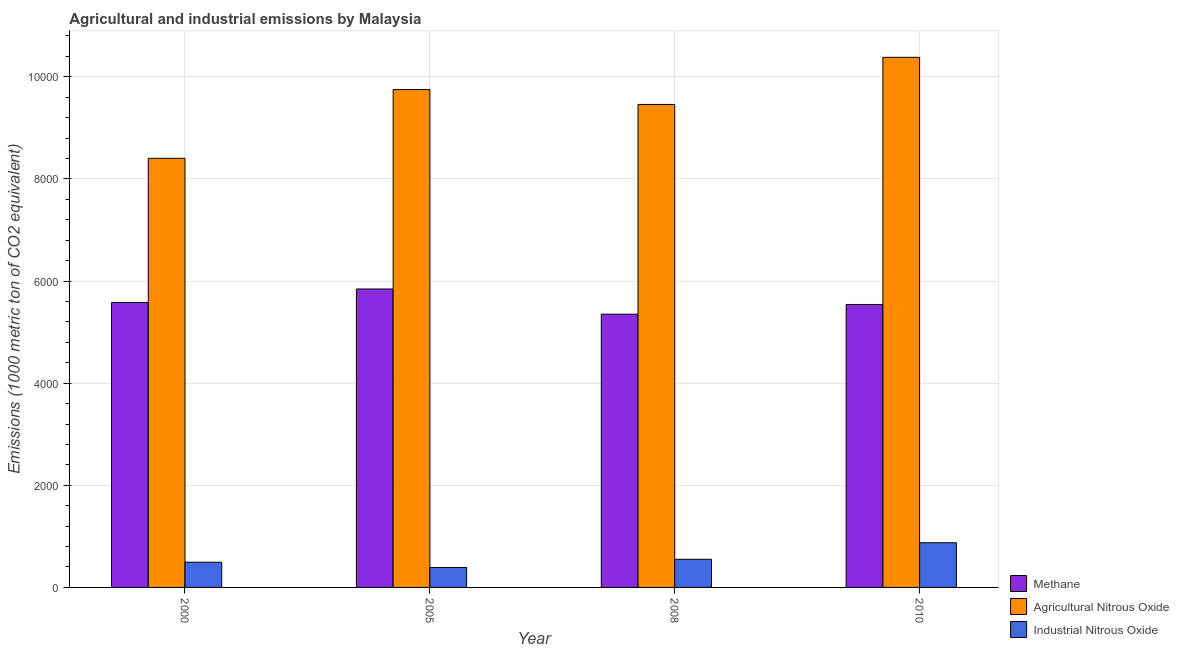What is the amount of agricultural nitrous oxide emissions in 2000?
Your answer should be compact. 8403.2. Across all years, what is the maximum amount of industrial nitrous oxide emissions?
Your answer should be very brief. 874.9. Across all years, what is the minimum amount of agricultural nitrous oxide emissions?
Give a very brief answer. 8403.2. In which year was the amount of agricultural nitrous oxide emissions minimum?
Keep it short and to the point. 2000. What is the total amount of methane emissions in the graph?
Keep it short and to the point. 2.23e+04. What is the difference between the amount of agricultural nitrous oxide emissions in 2005 and that in 2008?
Keep it short and to the point. 291.7. What is the difference between the amount of methane emissions in 2000 and the amount of industrial nitrous oxide emissions in 2008?
Provide a succinct answer. 228.9. What is the average amount of industrial nitrous oxide emissions per year?
Give a very brief answer. 577.65. In the year 2010, what is the difference between the amount of industrial nitrous oxide emissions and amount of methane emissions?
Offer a very short reply. 0. What is the ratio of the amount of industrial nitrous oxide emissions in 2000 to that in 2005?
Offer a very short reply. 1.26. Is the difference between the amount of industrial nitrous oxide emissions in 2000 and 2010 greater than the difference between the amount of agricultural nitrous oxide emissions in 2000 and 2010?
Provide a succinct answer. No. What is the difference between the highest and the second highest amount of agricultural nitrous oxide emissions?
Your answer should be very brief. 630.9. What is the difference between the highest and the lowest amount of methane emissions?
Ensure brevity in your answer.  493.7. What does the 3rd bar from the left in 2008 represents?
Offer a very short reply. Industrial Nitrous Oxide. What does the 3rd bar from the right in 2000 represents?
Your answer should be compact. Methane. Is it the case that in every year, the sum of the amount of methane emissions and amount of agricultural nitrous oxide emissions is greater than the amount of industrial nitrous oxide emissions?
Ensure brevity in your answer.  Yes. How many bars are there?
Give a very brief answer. 12. What is the difference between two consecutive major ticks on the Y-axis?
Your answer should be very brief. 2000. Does the graph contain any zero values?
Ensure brevity in your answer.  No. How many legend labels are there?
Keep it short and to the point. 3. What is the title of the graph?
Provide a succinct answer. Agricultural and industrial emissions by Malaysia. Does "Agricultural Nitrous Oxide" appear as one of the legend labels in the graph?
Offer a terse response. Yes. What is the label or title of the Y-axis?
Give a very brief answer. Emissions (1000 metric ton of CO2 equivalent). What is the Emissions (1000 metric ton of CO2 equivalent) in Methane in 2000?
Make the answer very short. 5579.2. What is the Emissions (1000 metric ton of CO2 equivalent) in Agricultural Nitrous Oxide in 2000?
Provide a succinct answer. 8403.2. What is the Emissions (1000 metric ton of CO2 equivalent) in Industrial Nitrous Oxide in 2000?
Ensure brevity in your answer.  493.8. What is the Emissions (1000 metric ton of CO2 equivalent) in Methane in 2005?
Keep it short and to the point. 5844. What is the Emissions (1000 metric ton of CO2 equivalent) of Agricultural Nitrous Oxide in 2005?
Your response must be concise. 9749.3. What is the Emissions (1000 metric ton of CO2 equivalent) in Industrial Nitrous Oxide in 2005?
Make the answer very short. 390.9. What is the Emissions (1000 metric ton of CO2 equivalent) in Methane in 2008?
Make the answer very short. 5350.3. What is the Emissions (1000 metric ton of CO2 equivalent) in Agricultural Nitrous Oxide in 2008?
Make the answer very short. 9457.6. What is the Emissions (1000 metric ton of CO2 equivalent) of Industrial Nitrous Oxide in 2008?
Your answer should be compact. 551. What is the Emissions (1000 metric ton of CO2 equivalent) of Methane in 2010?
Ensure brevity in your answer.  5540.3. What is the Emissions (1000 metric ton of CO2 equivalent) in Agricultural Nitrous Oxide in 2010?
Keep it short and to the point. 1.04e+04. What is the Emissions (1000 metric ton of CO2 equivalent) of Industrial Nitrous Oxide in 2010?
Ensure brevity in your answer.  874.9. Across all years, what is the maximum Emissions (1000 metric ton of CO2 equivalent) of Methane?
Offer a very short reply. 5844. Across all years, what is the maximum Emissions (1000 metric ton of CO2 equivalent) of Agricultural Nitrous Oxide?
Offer a terse response. 1.04e+04. Across all years, what is the maximum Emissions (1000 metric ton of CO2 equivalent) of Industrial Nitrous Oxide?
Offer a terse response. 874.9. Across all years, what is the minimum Emissions (1000 metric ton of CO2 equivalent) in Methane?
Give a very brief answer. 5350.3. Across all years, what is the minimum Emissions (1000 metric ton of CO2 equivalent) in Agricultural Nitrous Oxide?
Ensure brevity in your answer.  8403.2. Across all years, what is the minimum Emissions (1000 metric ton of CO2 equivalent) of Industrial Nitrous Oxide?
Give a very brief answer. 390.9. What is the total Emissions (1000 metric ton of CO2 equivalent) in Methane in the graph?
Ensure brevity in your answer.  2.23e+04. What is the total Emissions (1000 metric ton of CO2 equivalent) of Agricultural Nitrous Oxide in the graph?
Provide a short and direct response. 3.80e+04. What is the total Emissions (1000 metric ton of CO2 equivalent) of Industrial Nitrous Oxide in the graph?
Provide a short and direct response. 2310.6. What is the difference between the Emissions (1000 metric ton of CO2 equivalent) in Methane in 2000 and that in 2005?
Make the answer very short. -264.8. What is the difference between the Emissions (1000 metric ton of CO2 equivalent) in Agricultural Nitrous Oxide in 2000 and that in 2005?
Provide a succinct answer. -1346.1. What is the difference between the Emissions (1000 metric ton of CO2 equivalent) in Industrial Nitrous Oxide in 2000 and that in 2005?
Provide a succinct answer. 102.9. What is the difference between the Emissions (1000 metric ton of CO2 equivalent) in Methane in 2000 and that in 2008?
Your response must be concise. 228.9. What is the difference between the Emissions (1000 metric ton of CO2 equivalent) of Agricultural Nitrous Oxide in 2000 and that in 2008?
Provide a short and direct response. -1054.4. What is the difference between the Emissions (1000 metric ton of CO2 equivalent) of Industrial Nitrous Oxide in 2000 and that in 2008?
Your response must be concise. -57.2. What is the difference between the Emissions (1000 metric ton of CO2 equivalent) of Methane in 2000 and that in 2010?
Provide a succinct answer. 38.9. What is the difference between the Emissions (1000 metric ton of CO2 equivalent) in Agricultural Nitrous Oxide in 2000 and that in 2010?
Keep it short and to the point. -1977. What is the difference between the Emissions (1000 metric ton of CO2 equivalent) of Industrial Nitrous Oxide in 2000 and that in 2010?
Provide a short and direct response. -381.1. What is the difference between the Emissions (1000 metric ton of CO2 equivalent) in Methane in 2005 and that in 2008?
Keep it short and to the point. 493.7. What is the difference between the Emissions (1000 metric ton of CO2 equivalent) in Agricultural Nitrous Oxide in 2005 and that in 2008?
Provide a succinct answer. 291.7. What is the difference between the Emissions (1000 metric ton of CO2 equivalent) in Industrial Nitrous Oxide in 2005 and that in 2008?
Your answer should be very brief. -160.1. What is the difference between the Emissions (1000 metric ton of CO2 equivalent) of Methane in 2005 and that in 2010?
Offer a terse response. 303.7. What is the difference between the Emissions (1000 metric ton of CO2 equivalent) in Agricultural Nitrous Oxide in 2005 and that in 2010?
Give a very brief answer. -630.9. What is the difference between the Emissions (1000 metric ton of CO2 equivalent) of Industrial Nitrous Oxide in 2005 and that in 2010?
Your answer should be compact. -484. What is the difference between the Emissions (1000 metric ton of CO2 equivalent) of Methane in 2008 and that in 2010?
Make the answer very short. -190. What is the difference between the Emissions (1000 metric ton of CO2 equivalent) of Agricultural Nitrous Oxide in 2008 and that in 2010?
Provide a short and direct response. -922.6. What is the difference between the Emissions (1000 metric ton of CO2 equivalent) of Industrial Nitrous Oxide in 2008 and that in 2010?
Make the answer very short. -323.9. What is the difference between the Emissions (1000 metric ton of CO2 equivalent) in Methane in 2000 and the Emissions (1000 metric ton of CO2 equivalent) in Agricultural Nitrous Oxide in 2005?
Offer a terse response. -4170.1. What is the difference between the Emissions (1000 metric ton of CO2 equivalent) in Methane in 2000 and the Emissions (1000 metric ton of CO2 equivalent) in Industrial Nitrous Oxide in 2005?
Ensure brevity in your answer.  5188.3. What is the difference between the Emissions (1000 metric ton of CO2 equivalent) of Agricultural Nitrous Oxide in 2000 and the Emissions (1000 metric ton of CO2 equivalent) of Industrial Nitrous Oxide in 2005?
Your response must be concise. 8012.3. What is the difference between the Emissions (1000 metric ton of CO2 equivalent) in Methane in 2000 and the Emissions (1000 metric ton of CO2 equivalent) in Agricultural Nitrous Oxide in 2008?
Your answer should be very brief. -3878.4. What is the difference between the Emissions (1000 metric ton of CO2 equivalent) in Methane in 2000 and the Emissions (1000 metric ton of CO2 equivalent) in Industrial Nitrous Oxide in 2008?
Provide a short and direct response. 5028.2. What is the difference between the Emissions (1000 metric ton of CO2 equivalent) of Agricultural Nitrous Oxide in 2000 and the Emissions (1000 metric ton of CO2 equivalent) of Industrial Nitrous Oxide in 2008?
Offer a terse response. 7852.2. What is the difference between the Emissions (1000 metric ton of CO2 equivalent) of Methane in 2000 and the Emissions (1000 metric ton of CO2 equivalent) of Agricultural Nitrous Oxide in 2010?
Provide a succinct answer. -4801. What is the difference between the Emissions (1000 metric ton of CO2 equivalent) in Methane in 2000 and the Emissions (1000 metric ton of CO2 equivalent) in Industrial Nitrous Oxide in 2010?
Your answer should be compact. 4704.3. What is the difference between the Emissions (1000 metric ton of CO2 equivalent) in Agricultural Nitrous Oxide in 2000 and the Emissions (1000 metric ton of CO2 equivalent) in Industrial Nitrous Oxide in 2010?
Your response must be concise. 7528.3. What is the difference between the Emissions (1000 metric ton of CO2 equivalent) in Methane in 2005 and the Emissions (1000 metric ton of CO2 equivalent) in Agricultural Nitrous Oxide in 2008?
Provide a short and direct response. -3613.6. What is the difference between the Emissions (1000 metric ton of CO2 equivalent) of Methane in 2005 and the Emissions (1000 metric ton of CO2 equivalent) of Industrial Nitrous Oxide in 2008?
Give a very brief answer. 5293. What is the difference between the Emissions (1000 metric ton of CO2 equivalent) of Agricultural Nitrous Oxide in 2005 and the Emissions (1000 metric ton of CO2 equivalent) of Industrial Nitrous Oxide in 2008?
Ensure brevity in your answer.  9198.3. What is the difference between the Emissions (1000 metric ton of CO2 equivalent) in Methane in 2005 and the Emissions (1000 metric ton of CO2 equivalent) in Agricultural Nitrous Oxide in 2010?
Your answer should be very brief. -4536.2. What is the difference between the Emissions (1000 metric ton of CO2 equivalent) of Methane in 2005 and the Emissions (1000 metric ton of CO2 equivalent) of Industrial Nitrous Oxide in 2010?
Keep it short and to the point. 4969.1. What is the difference between the Emissions (1000 metric ton of CO2 equivalent) of Agricultural Nitrous Oxide in 2005 and the Emissions (1000 metric ton of CO2 equivalent) of Industrial Nitrous Oxide in 2010?
Provide a succinct answer. 8874.4. What is the difference between the Emissions (1000 metric ton of CO2 equivalent) of Methane in 2008 and the Emissions (1000 metric ton of CO2 equivalent) of Agricultural Nitrous Oxide in 2010?
Provide a short and direct response. -5029.9. What is the difference between the Emissions (1000 metric ton of CO2 equivalent) in Methane in 2008 and the Emissions (1000 metric ton of CO2 equivalent) in Industrial Nitrous Oxide in 2010?
Make the answer very short. 4475.4. What is the difference between the Emissions (1000 metric ton of CO2 equivalent) in Agricultural Nitrous Oxide in 2008 and the Emissions (1000 metric ton of CO2 equivalent) in Industrial Nitrous Oxide in 2010?
Make the answer very short. 8582.7. What is the average Emissions (1000 metric ton of CO2 equivalent) of Methane per year?
Provide a succinct answer. 5578.45. What is the average Emissions (1000 metric ton of CO2 equivalent) in Agricultural Nitrous Oxide per year?
Make the answer very short. 9497.58. What is the average Emissions (1000 metric ton of CO2 equivalent) in Industrial Nitrous Oxide per year?
Your answer should be compact. 577.65. In the year 2000, what is the difference between the Emissions (1000 metric ton of CO2 equivalent) in Methane and Emissions (1000 metric ton of CO2 equivalent) in Agricultural Nitrous Oxide?
Offer a terse response. -2824. In the year 2000, what is the difference between the Emissions (1000 metric ton of CO2 equivalent) in Methane and Emissions (1000 metric ton of CO2 equivalent) in Industrial Nitrous Oxide?
Your answer should be very brief. 5085.4. In the year 2000, what is the difference between the Emissions (1000 metric ton of CO2 equivalent) of Agricultural Nitrous Oxide and Emissions (1000 metric ton of CO2 equivalent) of Industrial Nitrous Oxide?
Offer a very short reply. 7909.4. In the year 2005, what is the difference between the Emissions (1000 metric ton of CO2 equivalent) of Methane and Emissions (1000 metric ton of CO2 equivalent) of Agricultural Nitrous Oxide?
Make the answer very short. -3905.3. In the year 2005, what is the difference between the Emissions (1000 metric ton of CO2 equivalent) in Methane and Emissions (1000 metric ton of CO2 equivalent) in Industrial Nitrous Oxide?
Offer a terse response. 5453.1. In the year 2005, what is the difference between the Emissions (1000 metric ton of CO2 equivalent) in Agricultural Nitrous Oxide and Emissions (1000 metric ton of CO2 equivalent) in Industrial Nitrous Oxide?
Offer a very short reply. 9358.4. In the year 2008, what is the difference between the Emissions (1000 metric ton of CO2 equivalent) in Methane and Emissions (1000 metric ton of CO2 equivalent) in Agricultural Nitrous Oxide?
Provide a succinct answer. -4107.3. In the year 2008, what is the difference between the Emissions (1000 metric ton of CO2 equivalent) in Methane and Emissions (1000 metric ton of CO2 equivalent) in Industrial Nitrous Oxide?
Provide a short and direct response. 4799.3. In the year 2008, what is the difference between the Emissions (1000 metric ton of CO2 equivalent) in Agricultural Nitrous Oxide and Emissions (1000 metric ton of CO2 equivalent) in Industrial Nitrous Oxide?
Give a very brief answer. 8906.6. In the year 2010, what is the difference between the Emissions (1000 metric ton of CO2 equivalent) in Methane and Emissions (1000 metric ton of CO2 equivalent) in Agricultural Nitrous Oxide?
Your answer should be very brief. -4839.9. In the year 2010, what is the difference between the Emissions (1000 metric ton of CO2 equivalent) of Methane and Emissions (1000 metric ton of CO2 equivalent) of Industrial Nitrous Oxide?
Your answer should be very brief. 4665.4. In the year 2010, what is the difference between the Emissions (1000 metric ton of CO2 equivalent) in Agricultural Nitrous Oxide and Emissions (1000 metric ton of CO2 equivalent) in Industrial Nitrous Oxide?
Offer a terse response. 9505.3. What is the ratio of the Emissions (1000 metric ton of CO2 equivalent) of Methane in 2000 to that in 2005?
Provide a short and direct response. 0.95. What is the ratio of the Emissions (1000 metric ton of CO2 equivalent) in Agricultural Nitrous Oxide in 2000 to that in 2005?
Make the answer very short. 0.86. What is the ratio of the Emissions (1000 metric ton of CO2 equivalent) of Industrial Nitrous Oxide in 2000 to that in 2005?
Keep it short and to the point. 1.26. What is the ratio of the Emissions (1000 metric ton of CO2 equivalent) in Methane in 2000 to that in 2008?
Keep it short and to the point. 1.04. What is the ratio of the Emissions (1000 metric ton of CO2 equivalent) of Agricultural Nitrous Oxide in 2000 to that in 2008?
Your response must be concise. 0.89. What is the ratio of the Emissions (1000 metric ton of CO2 equivalent) in Industrial Nitrous Oxide in 2000 to that in 2008?
Give a very brief answer. 0.9. What is the ratio of the Emissions (1000 metric ton of CO2 equivalent) in Methane in 2000 to that in 2010?
Offer a very short reply. 1.01. What is the ratio of the Emissions (1000 metric ton of CO2 equivalent) in Agricultural Nitrous Oxide in 2000 to that in 2010?
Give a very brief answer. 0.81. What is the ratio of the Emissions (1000 metric ton of CO2 equivalent) in Industrial Nitrous Oxide in 2000 to that in 2010?
Make the answer very short. 0.56. What is the ratio of the Emissions (1000 metric ton of CO2 equivalent) in Methane in 2005 to that in 2008?
Offer a terse response. 1.09. What is the ratio of the Emissions (1000 metric ton of CO2 equivalent) of Agricultural Nitrous Oxide in 2005 to that in 2008?
Offer a very short reply. 1.03. What is the ratio of the Emissions (1000 metric ton of CO2 equivalent) in Industrial Nitrous Oxide in 2005 to that in 2008?
Provide a succinct answer. 0.71. What is the ratio of the Emissions (1000 metric ton of CO2 equivalent) in Methane in 2005 to that in 2010?
Your answer should be very brief. 1.05. What is the ratio of the Emissions (1000 metric ton of CO2 equivalent) of Agricultural Nitrous Oxide in 2005 to that in 2010?
Keep it short and to the point. 0.94. What is the ratio of the Emissions (1000 metric ton of CO2 equivalent) of Industrial Nitrous Oxide in 2005 to that in 2010?
Offer a very short reply. 0.45. What is the ratio of the Emissions (1000 metric ton of CO2 equivalent) of Methane in 2008 to that in 2010?
Your answer should be compact. 0.97. What is the ratio of the Emissions (1000 metric ton of CO2 equivalent) in Agricultural Nitrous Oxide in 2008 to that in 2010?
Keep it short and to the point. 0.91. What is the ratio of the Emissions (1000 metric ton of CO2 equivalent) of Industrial Nitrous Oxide in 2008 to that in 2010?
Give a very brief answer. 0.63. What is the difference between the highest and the second highest Emissions (1000 metric ton of CO2 equivalent) in Methane?
Offer a very short reply. 264.8. What is the difference between the highest and the second highest Emissions (1000 metric ton of CO2 equivalent) in Agricultural Nitrous Oxide?
Give a very brief answer. 630.9. What is the difference between the highest and the second highest Emissions (1000 metric ton of CO2 equivalent) in Industrial Nitrous Oxide?
Your response must be concise. 323.9. What is the difference between the highest and the lowest Emissions (1000 metric ton of CO2 equivalent) of Methane?
Ensure brevity in your answer.  493.7. What is the difference between the highest and the lowest Emissions (1000 metric ton of CO2 equivalent) in Agricultural Nitrous Oxide?
Provide a succinct answer. 1977. What is the difference between the highest and the lowest Emissions (1000 metric ton of CO2 equivalent) of Industrial Nitrous Oxide?
Offer a very short reply. 484. 